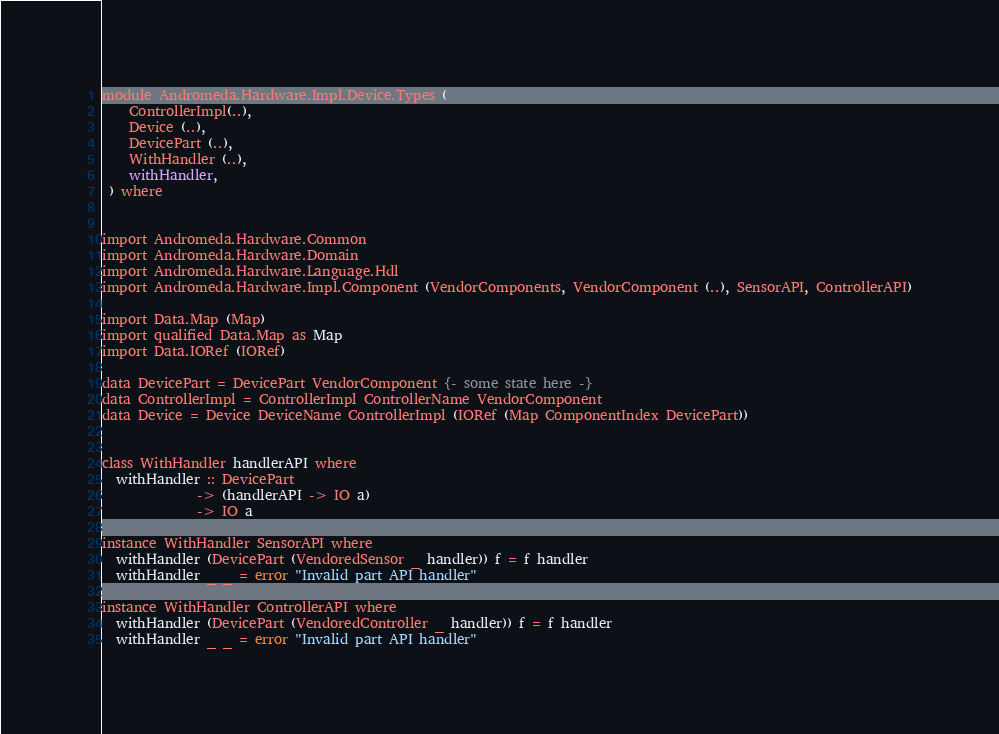<code> <loc_0><loc_0><loc_500><loc_500><_Haskell_>module Andromeda.Hardware.Impl.Device.Types (
    ControllerImpl(..),
    Device (..),
    DevicePart (..),
    WithHandler (..),
    withHandler,
 ) where


import Andromeda.Hardware.Common
import Andromeda.Hardware.Domain
import Andromeda.Hardware.Language.Hdl
import Andromeda.Hardware.Impl.Component (VendorComponents, VendorComponent (..), SensorAPI, ControllerAPI)

import Data.Map (Map)
import qualified Data.Map as Map
import Data.IORef (IORef)

data DevicePart = DevicePart VendorComponent {- some state here -}
data ControllerImpl = ControllerImpl ControllerName VendorComponent
data Device = Device DeviceName ControllerImpl (IORef (Map ComponentIndex DevicePart))


class WithHandler handlerAPI where
  withHandler :: DevicePart
              -> (handlerAPI -> IO a)
              -> IO a

instance WithHandler SensorAPI where
  withHandler (DevicePart (VendoredSensor _ handler)) f = f handler
  withHandler _ _ = error "Invalid part API handler"

instance WithHandler ControllerAPI where
  withHandler (DevicePart (VendoredController _ handler)) f = f handler
  withHandler _ _ = error "Invalid part API handler"
</code> 